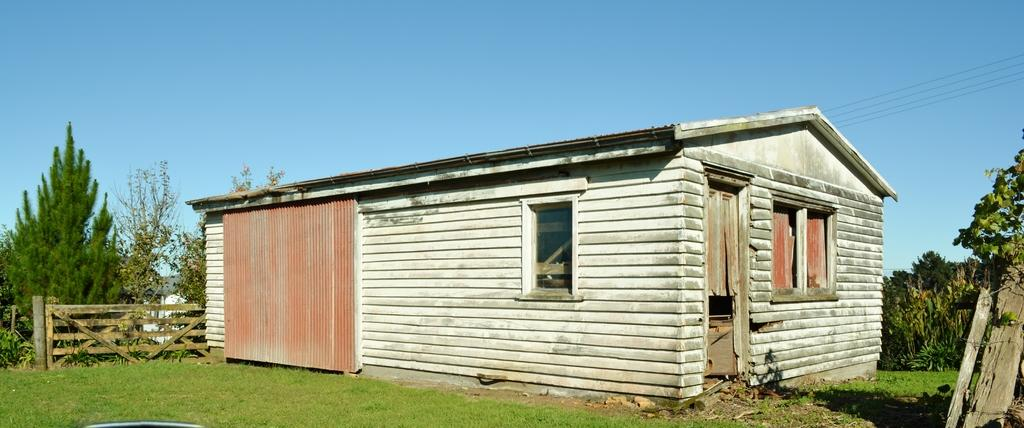What type of landscape is depicted in the image? There is a grassland in the image. What structure can be seen on the grassland? There is a shed on the grassland. What type of barrier is present in the image? There is a wooden railing in the image. What can be seen in the distance in the image? There are trees and the sky visible in the background of the image. What type of gun is being used in the battle depicted in the image? There is no battle or gun present in the image; it features a grassland with a shed, wooden railing, trees, and the sky. 